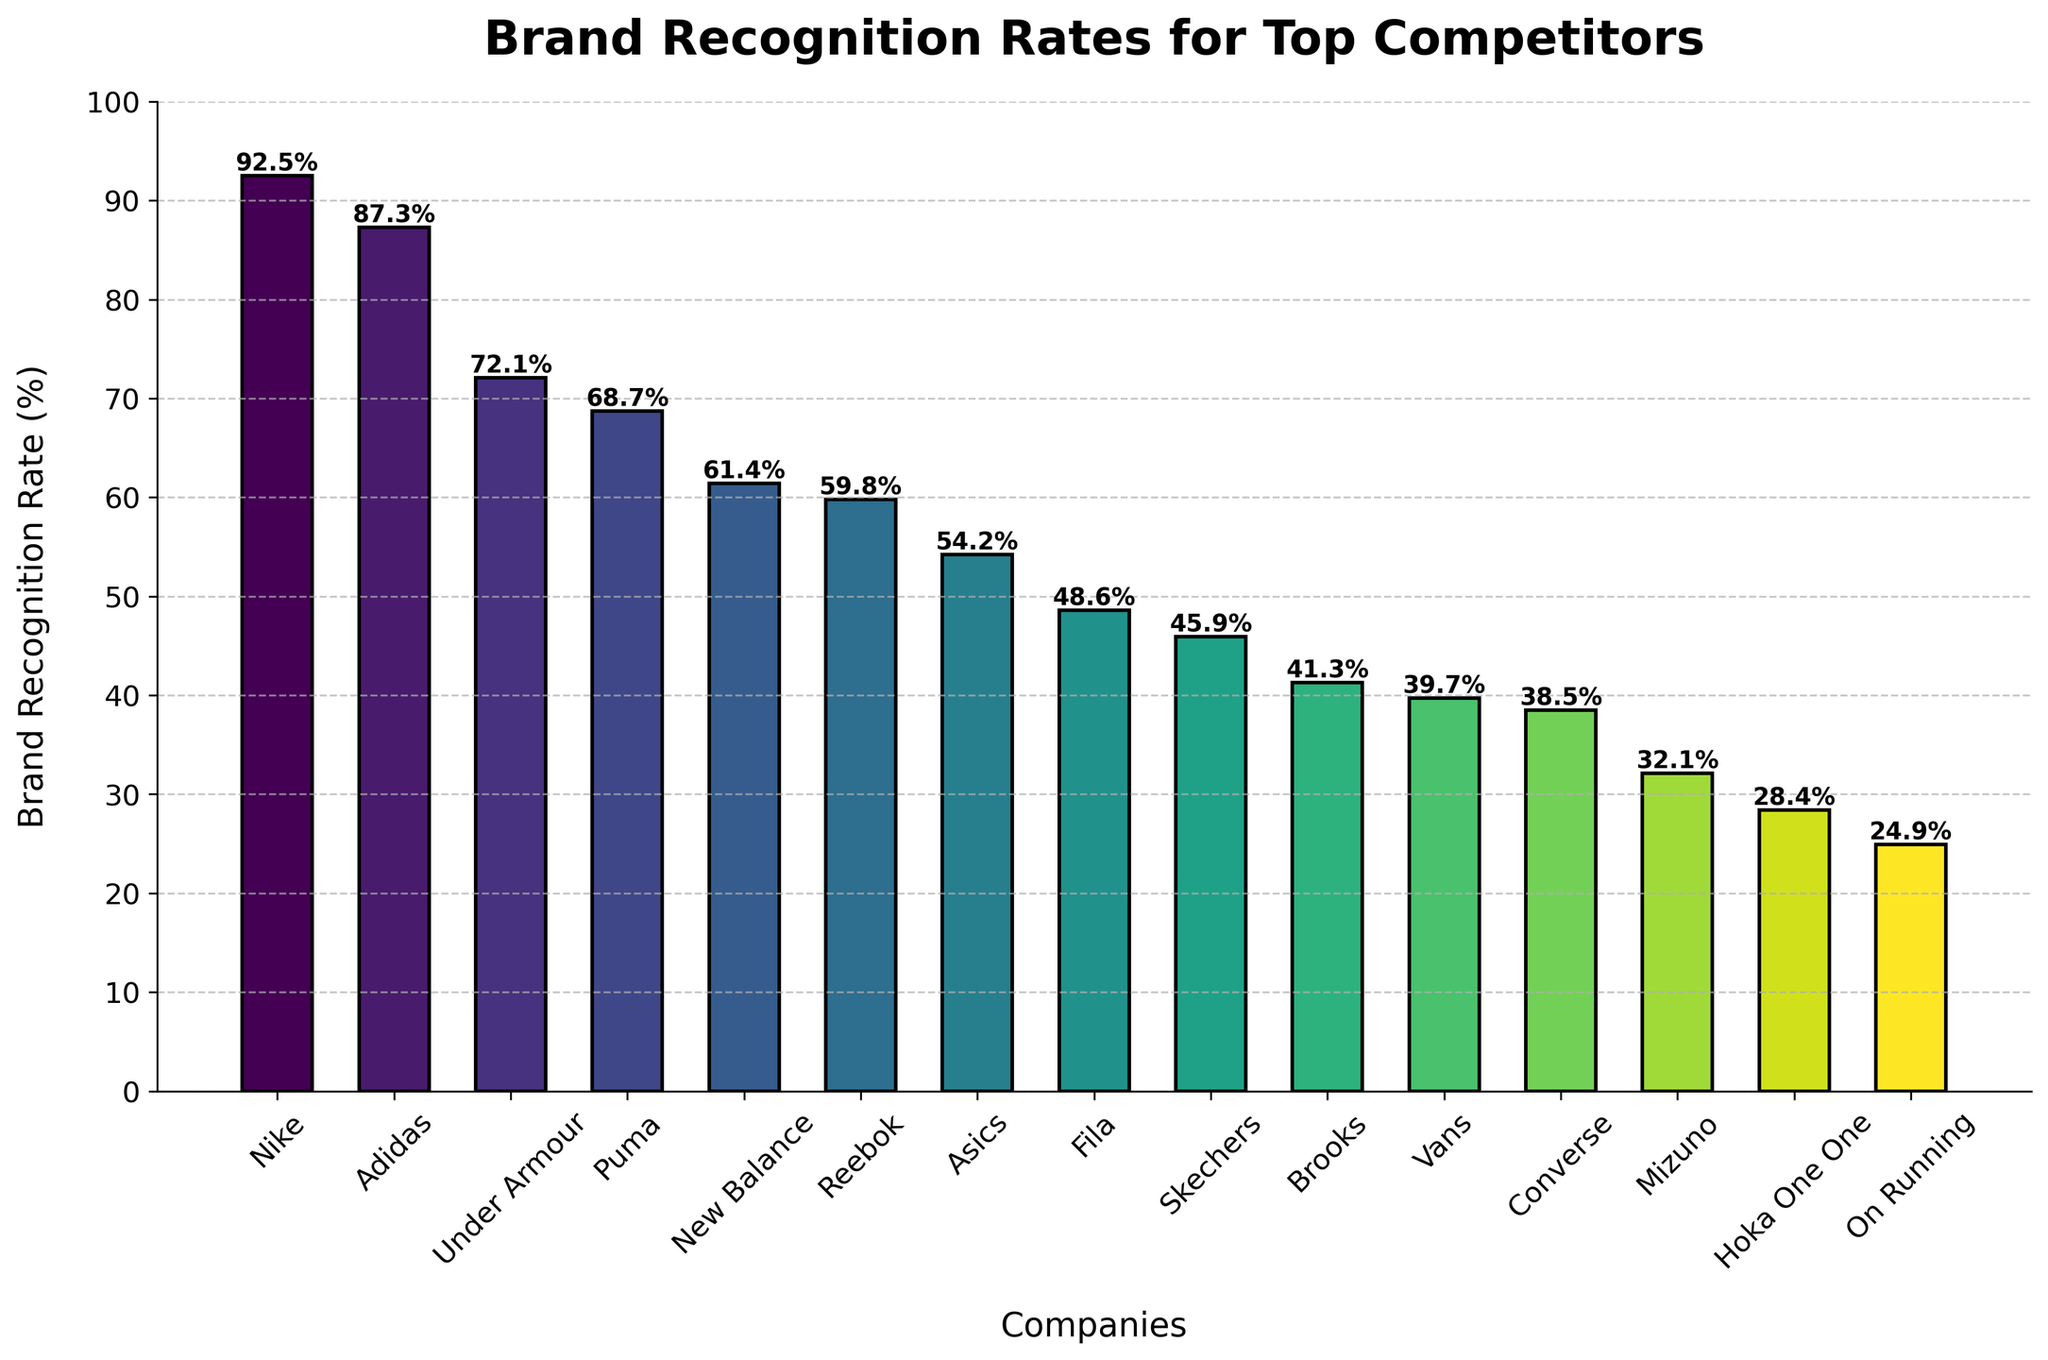How many companies have a brand recognition rate greater than 50%? There are 6 companies with a brand recognition rate greater than 50%: Nike, Adidas, Under Armour, Puma, New Balance, and Reebok.
Answer: 6 Which company has the lowest brand recognition rate? The company with the lowest bar has the lowest brand recognition rate. This is On Running with a rate of 24.9%.
Answer: On Running What's the difference in brand recognition rates between Nike and Puma? Nike has a rate of 92.5%, while Puma has a rate of 68.7%. The difference is 92.5% - 68.7% = 23.8%.
Answer: 23.8% What is the average brand recognition rate of Adidas and Under Armour? The brand recognition rates are 87.3% for Adidas and 72.1% for Under Armour. The average is (87.3 + 72.1) / 2 = 79.7%.
Answer: 79.7% Which companies have a brand recognition rate within the range of 40% to 60%? The companies with recognition rates within this range are Skechers (45.9%), Brooks (41.3%), and Vans (39.7%).
Answer: Skechers, Brooks, Vans What is the sum of the brand recognition rates for the bottom five companies? The bottom five companies are Fila (48.6%), Skechers (45.9%), Brooks (41.3%), Vans (39.7%), and Converse (38.5%). The sum is 48.6 + 45.9 + 41.3 + 39.7 + 38.5 = 214%.
Answer: 214% Which company has a higher brand recognition rate, Mizuno or Hoka One One? Mizuno has a brand recognition rate of 32.1%, while Hoka One One has a rate of 28.4%. Mizuno has the higher recognition rate.
Answer: Mizuno What is the median brand recognition rate of the listed companies? To find the median, we list the brand recognition rates in ascending order and find the middle value. The sorted list is: 
24.9, 28.4, 32.1, 38.5, 39.7, 41.3, 45.9, 48.6, 54.2, 59.8, 61.4, 68.7, 72.1, 87.3, 92.5. 
The middle value (median) is 48.6%.
Answer: 48.6% What is the range of brand recognition rates in the chart? The range is the difference between the highest and lowest brand recognition rates. The highest rate is 92.5% (Nike) and the lowest is 24.9% (On Running). The range is 92.5% - 24.9% = 67.6%.
Answer: 67.6% How many companies have a brand recognition rate below 40%? The companies with a recognition rate below 40% are Vans (39.7%), Converse (38.5%), Mizuno (32.1%), Hoka One One (28.4%), and On Running (24.9%). This totals 5 companies.
Answer: 5 